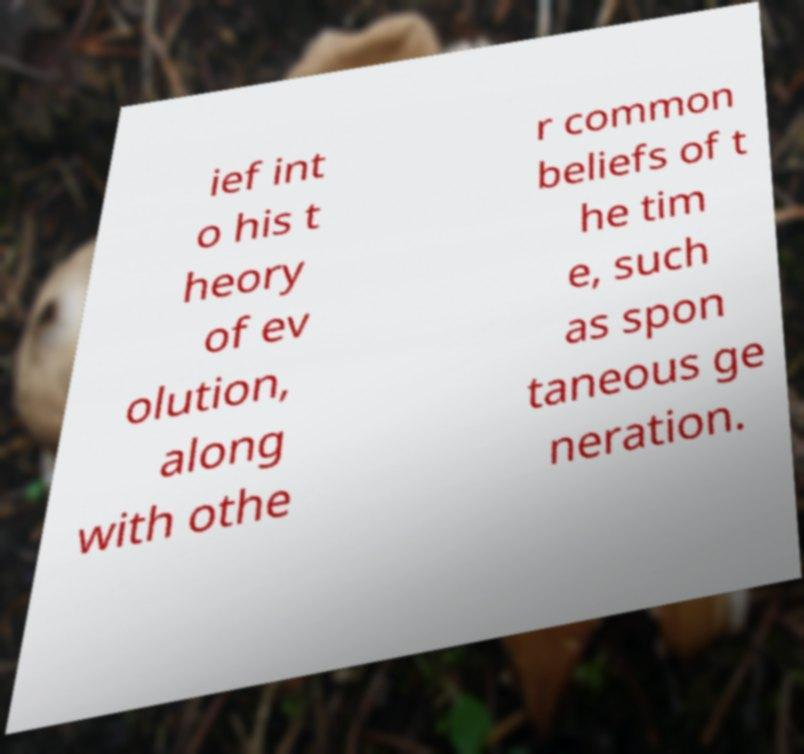Can you read and provide the text displayed in the image?This photo seems to have some interesting text. Can you extract and type it out for me? ief int o his t heory of ev olution, along with othe r common beliefs of t he tim e, such as spon taneous ge neration. 